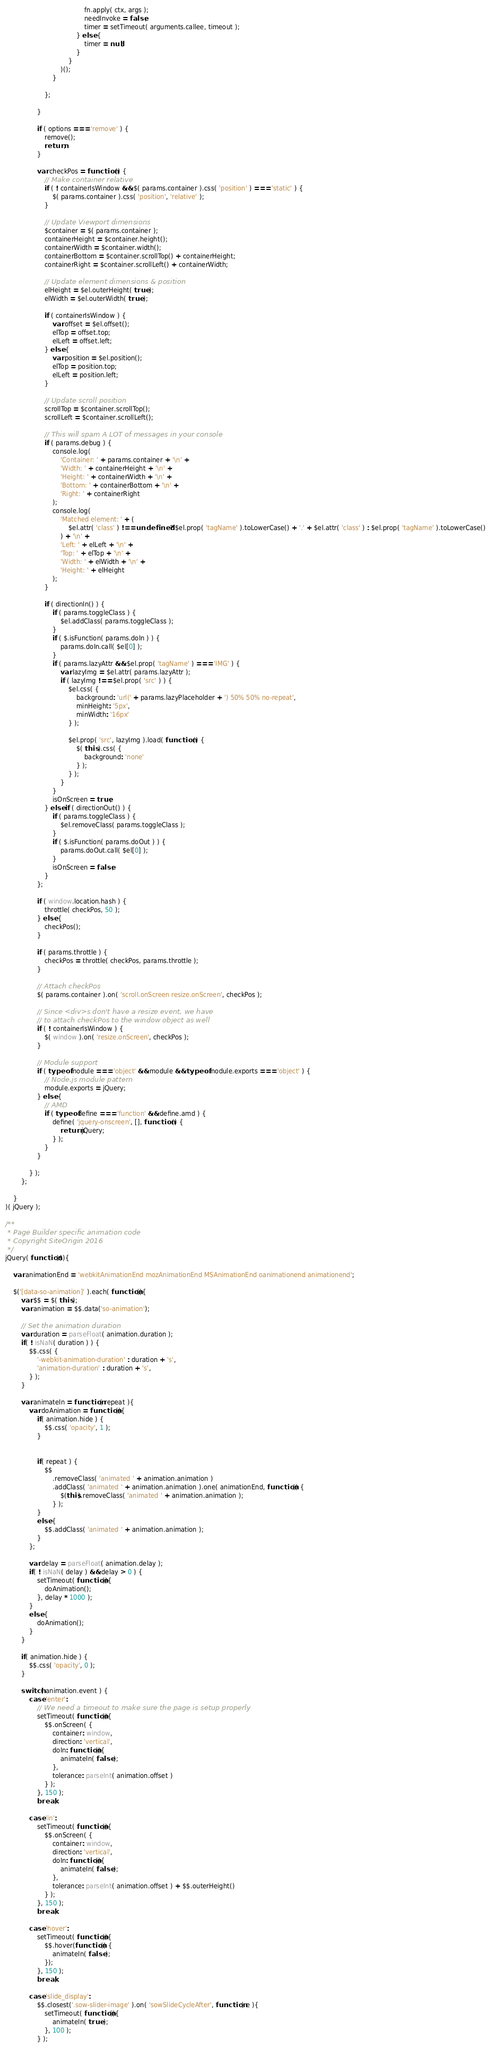Convert code to text. <code><loc_0><loc_0><loc_500><loc_500><_JavaScript_>										fn.apply( ctx, args );
										needInvoke = false;
										timer = setTimeout( arguments.callee, timeout );
									} else {
										timer = null;
									}
								}
							)();
						}

					};

				}

				if ( options === 'remove' ) {
					remove();
					return;
				}

				var checkPos = function () {
					// Make container relative
					if ( ! containerIsWindow && $( params.container ).css( 'position' ) === 'static' ) {
						$( params.container ).css( 'position', 'relative' );
					}

					// Update Viewport dimensions
					$container = $( params.container );
					containerHeight = $container.height();
					containerWidth = $container.width();
					containerBottom = $container.scrollTop() + containerHeight;
					containerRight = $container.scrollLeft() + containerWidth;

					// Update element dimensions & position
					elHeight = $el.outerHeight( true );
					elWidth = $el.outerWidth( true );

					if ( containerIsWindow ) {
						var offset = $el.offset();
						elTop = offset.top;
						elLeft = offset.left;
					} else {
						var position = $el.position();
						elTop = position.top;
						elLeft = position.left;
					}

					// Update scroll position
					scrollTop = $container.scrollTop();
					scrollLeft = $container.scrollLeft();

					// This will spam A LOT of messages in your console
					if ( params.debug ) {
						console.log(
							'Container: ' + params.container + '\n' +
							'Width: ' + containerHeight + '\n' +
							'Height: ' + containerWidth + '\n' +
							'Bottom: ' + containerBottom + '\n' +
							'Right: ' + containerRight
						);
						console.log(
							'Matched element: ' + (
								$el.attr( 'class' ) !== undefined ? $el.prop( 'tagName' ).toLowerCase() + '.' + $el.attr( 'class' ) : $el.prop( 'tagName' ).toLowerCase()
							) + '\n' +
							'Left: ' + elLeft + '\n' +
							'Top: ' + elTop + '\n' +
							'Width: ' + elWidth + '\n' +
							'Height: ' + elHeight
						);
					}

					if ( directionIn() ) {
						if ( params.toggleClass ) {
							$el.addClass( params.toggleClass );
						}
						if ( $.isFunction( params.doIn ) ) {
							params.doIn.call( $el[0] );
						}
						if ( params.lazyAttr && $el.prop( 'tagName' ) === 'IMG' ) {
							var lazyImg = $el.attr( params.lazyAttr );
							if ( lazyImg !== $el.prop( 'src' ) ) {
								$el.css( {
									background: 'url(' + params.lazyPlaceholder + ') 50% 50% no-repeat',
									minHeight: '5px',
									minWidth: '16px'
								} );

								$el.prop( 'src', lazyImg ).load( function () {
									$( this ).css( {
										background: 'none'
									} );
								} );
							}
						}
						isOnScreen = true;
					} else if ( directionOut() ) {
						if ( params.toggleClass ) {
							$el.removeClass( params.toggleClass );
						}
						if ( $.isFunction( params.doOut ) ) {
							params.doOut.call( $el[0] );
						}
						isOnScreen = false;
					}
				};

				if ( window.location.hash ) {
					throttle( checkPos, 50 );
				} else {
					checkPos();
				}

				if ( params.throttle ) {
					checkPos = throttle( checkPos, params.throttle );
				}

				// Attach checkPos
				$( params.container ).on( 'scroll.onScreen resize.onScreen', checkPos );

				// Since <div>s don't have a resize event, we have
				// to attach checkPos to the window object as well
				if ( ! containerIsWindow ) {
					$( window ).on( 'resize.onScreen', checkPos );
				}

				// Module support
				if ( typeof module === 'object' && module && typeof module.exports === 'object' ) {
					// Node.js module pattern
					module.exports = jQuery;
				} else {
					// AMD
					if ( typeof define === 'function' && define.amd ) {
						define( 'jquery-onscreen', [], function () {
							return jQuery;
						} );
					}
				}

			} );
		};

	}
)( jQuery );

/**
 * Page Builder specific animation code
 * Copyright SiteOrigin 2016
 */
jQuery( function($){

	var animationEnd = 'webkitAnimationEnd mozAnimationEnd MSAnimationEnd oanimationend animationend';

	$('[data-so-animation]' ).each( function(){
		var $$ = $( this );
		var animation = $$.data('so-animation');

		// Set the animation duration
		var duration = parseFloat( animation.duration );
		if( ! isNaN( duration ) ) {
			$$.css( {
				'-webkit-animation-duration' : duration + 's',
				'animation-duration' : duration + 's',
			} );
		}

		var animateIn = function( repeat ){
			var doAnimation = function(){
				if( animation.hide ) {
					$$.css( 'opacity', 1 );
				}


				if( repeat ) {
					$$
						.removeClass( 'animated ' + animation.animation )
						.addClass( 'animated ' + animation.animation ).one( animationEnd, function() {
							$(this).removeClass( 'animated ' + animation.animation );
						} );
				}
				else {
					$$.addClass( 'animated ' + animation.animation );
				}
			};

			var delay = parseFloat( animation.delay );
			if( ! isNaN( delay ) && delay > 0 ) {
				setTimeout( function(){
					doAnimation();
				}, delay * 1000 );
			}
			else {
				doAnimation();
			}
		}

		if( animation.hide ) {
			$$.css( 'opacity', 0 );
		}

		switch( animation.event ) {
			case 'enter':
				// We need a timeout to make sure the page is setup properly
				setTimeout( function(){
					$$.onScreen( {
						container: window,
						direction: 'vertical',
						doIn: function(){
							animateIn( false );
						},
						tolerance: parseInt( animation.offset )
					} );
				}, 150 );
				break;

			case 'in':
				setTimeout( function(){
					$$.onScreen( {
						container: window,
						direction: 'vertical',
						doIn: function(){
							animateIn( false );
						},
						tolerance: parseInt( animation.offset ) + $$.outerHeight()
					} );
				}, 150 );
				break;

			case 'hover':
				setTimeout( function(){
					$$.hover(function() {
						animateIn( false );
					});
				}, 150 );
				break;

			case 'slide_display':
				$$.closest('.sow-slider-image' ).on( 'sowSlideCycleAfter', function( e ){
					setTimeout( function(){
						animateIn( true );
					}, 100 );
				} );
</code> 